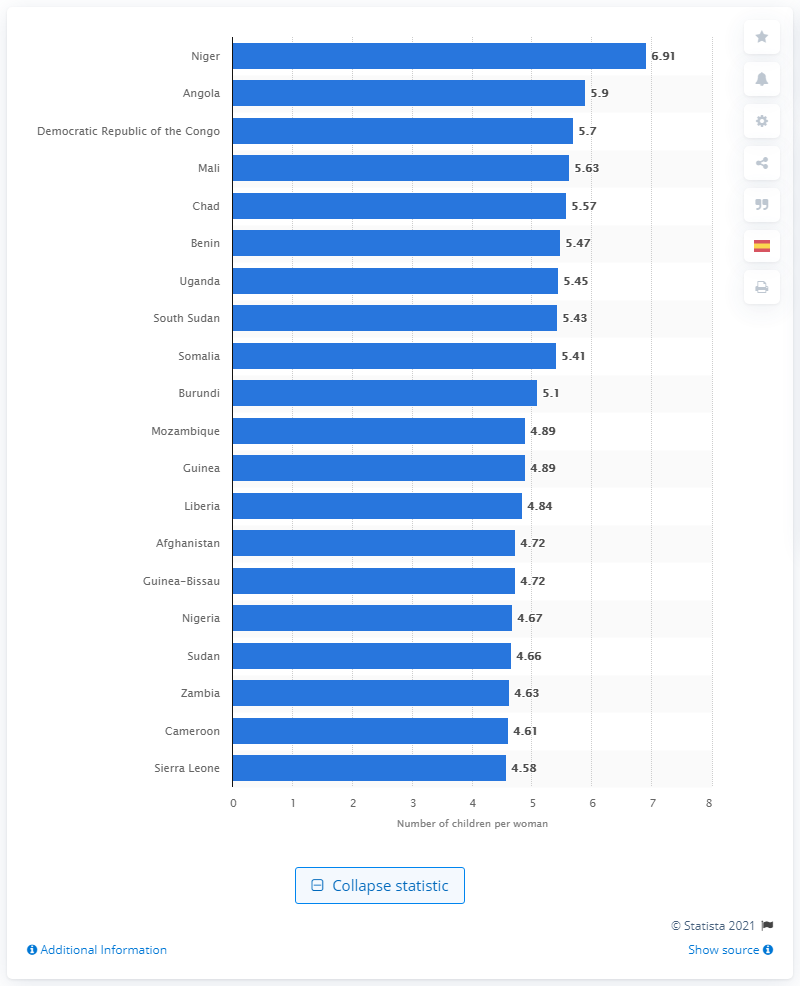Give some essential details in this illustration. According to data from 2021, the fertility rate in Niger was 6.91. 